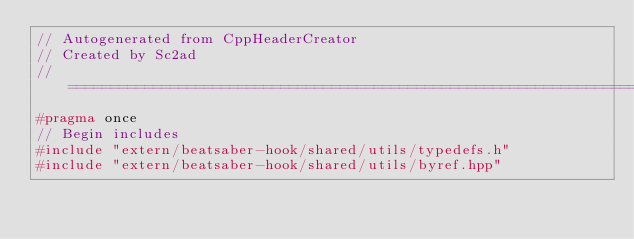<code> <loc_0><loc_0><loc_500><loc_500><_C++_>// Autogenerated from CppHeaderCreator
// Created by Sc2ad
// =========================================================================
#pragma once
// Begin includes
#include "extern/beatsaber-hook/shared/utils/typedefs.h"
#include "extern/beatsaber-hook/shared/utils/byref.hpp"</code> 